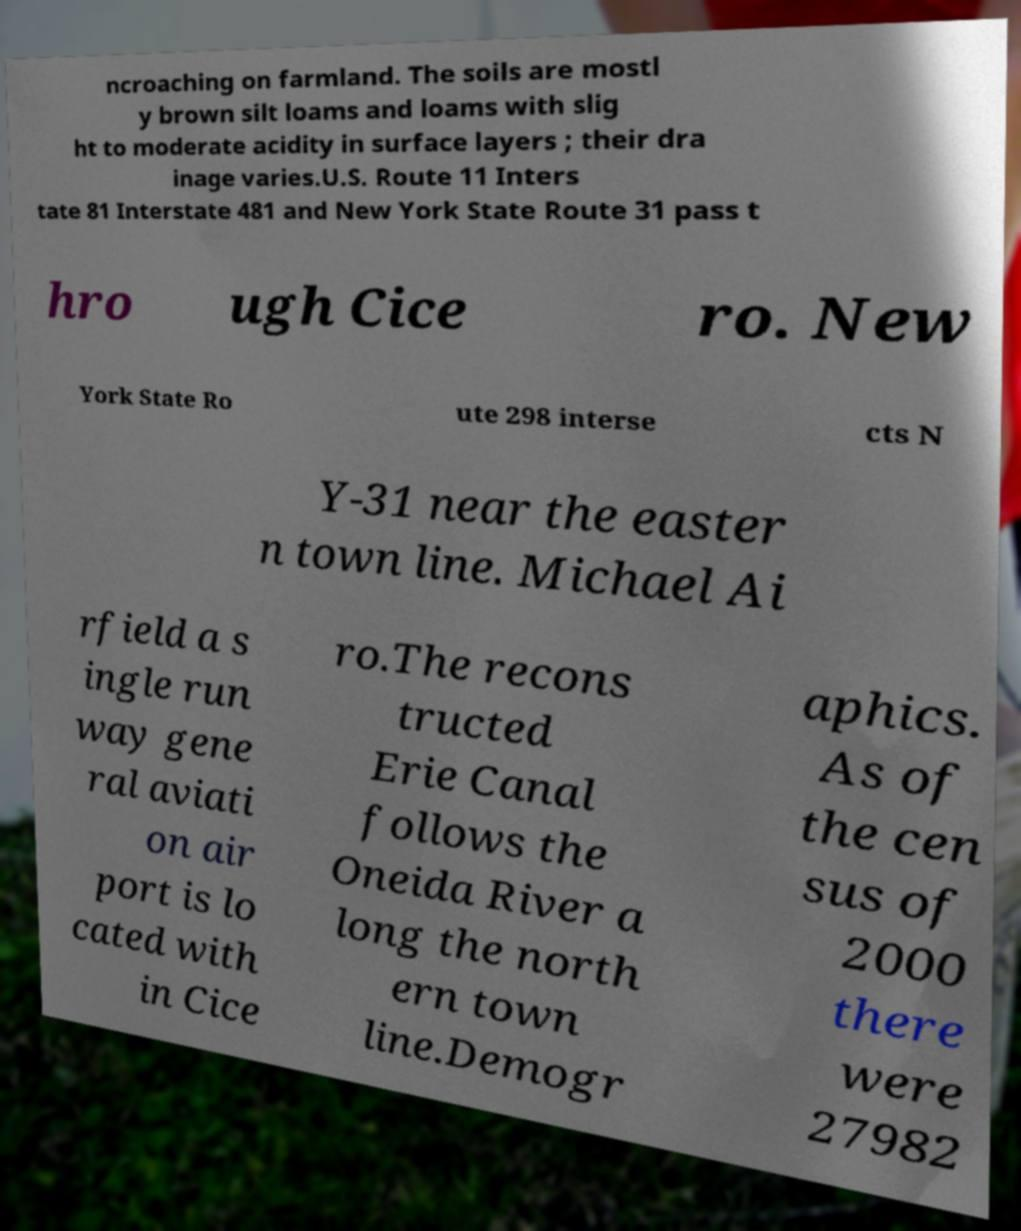Can you read and provide the text displayed in the image?This photo seems to have some interesting text. Can you extract and type it out for me? ncroaching on farmland. The soils are mostl y brown silt loams and loams with slig ht to moderate acidity in surface layers ; their dra inage varies.U.S. Route 11 Inters tate 81 Interstate 481 and New York State Route 31 pass t hro ugh Cice ro. New York State Ro ute 298 interse cts N Y-31 near the easter n town line. Michael Ai rfield a s ingle run way gene ral aviati on air port is lo cated with in Cice ro.The recons tructed Erie Canal follows the Oneida River a long the north ern town line.Demogr aphics. As of the cen sus of 2000 there were 27982 